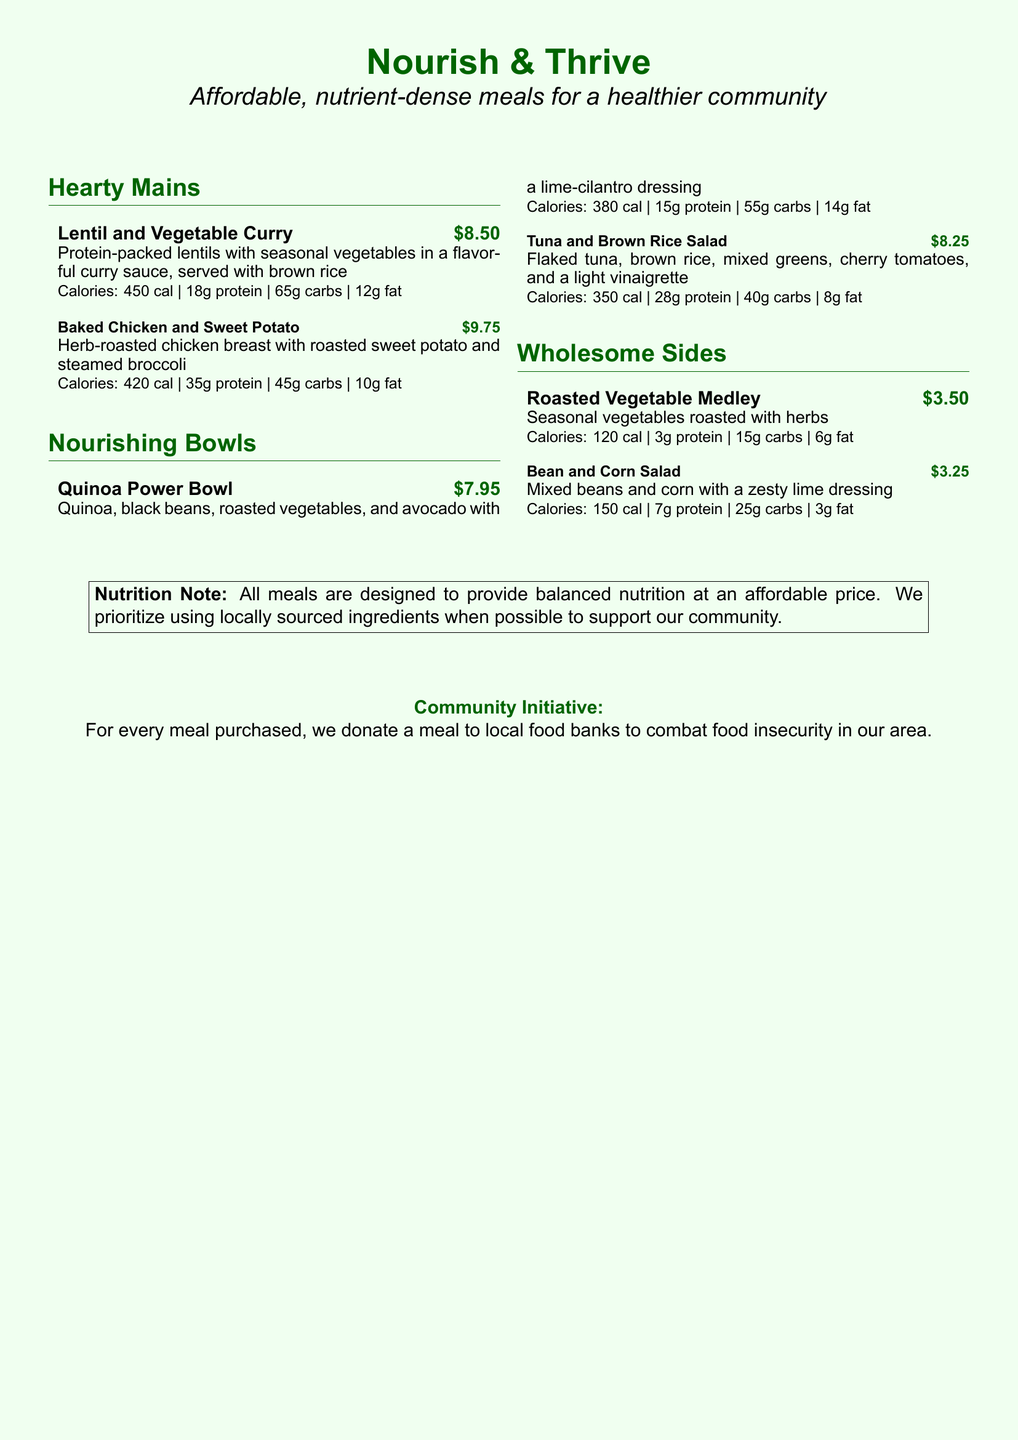what is the name of the restaurant? The restaurant's name is prominently displayed at the top of the document.
Answer: Nourish & Thrive what is the price of the Lentil and Vegetable Curry? The price is listed next to the dish name in the menu.
Answer: $8.50 how many grams of protein are in the Baked Chicken and Sweet Potato? The protein content is specified for each dish in the nutritional information section.
Answer: 35g protein how much do the Wholesome Sides cost? The prices for dishes under the Wholesome Sides section are indicated in the menu.
Answer: $3.50 and $3.25 what is the calorie count for the Quinoa Power Bowl? The calorie information is provided for each item in the nutritional breakdown.
Answer: 380 cal how many meals are donated for every meal purchased? The community initiative states the contribution ratio clearly.
Answer: One meal which dish contains black beans? The dish with black beans is mentioned in the Nourishing Bowls section of the menu.
Answer: Quinoa Power Bowl what is the key message in the Nutrition Note? The Nutrition Note emphasizes the intention behind the meal designs and sourcing.
Answer: Balanced nutrition at an affordable price what type of dressing is used in the Tuna and Brown Rice Salad? The dressing for this dish is described directly in the meal description.
Answer: Light vinaigrette 